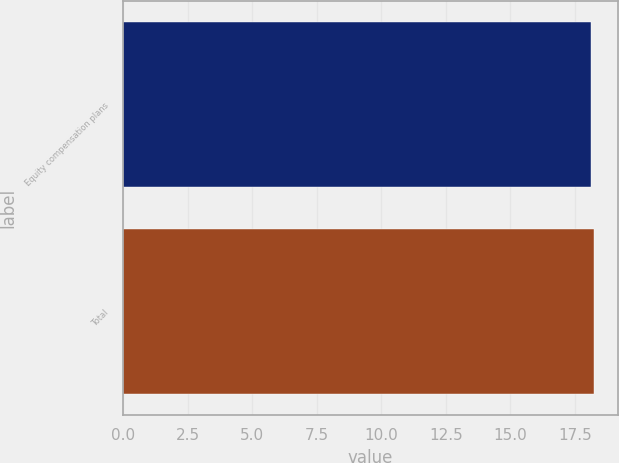Convert chart to OTSL. <chart><loc_0><loc_0><loc_500><loc_500><bar_chart><fcel>Equity compensation plans<fcel>Total<nl><fcel>18.15<fcel>18.25<nl></chart> 